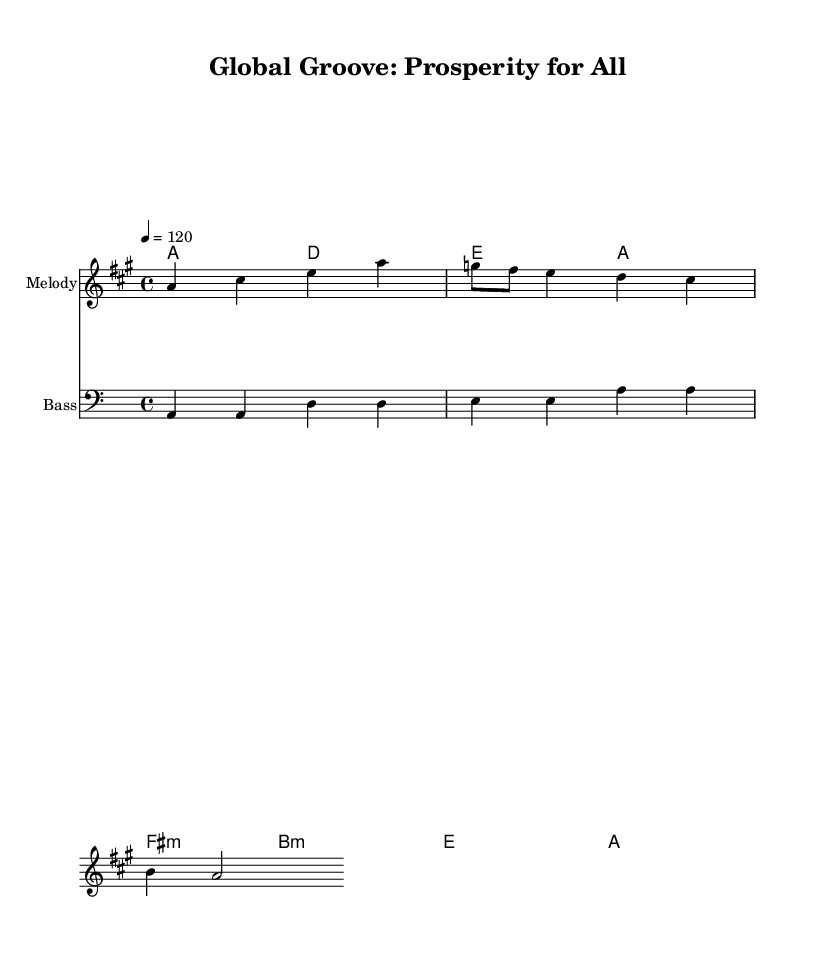What is the key signature of this music? The key signature is A major, which has three sharps: F sharp, C sharp, and G sharp. This can be seen in the global settings of the score.
Answer: A major What is the time signature of this music? The time signature is 4/4, meaning there are four beats in each measure and a quarter note gets one beat. This is specified in the global settings of the score.
Answer: 4/4 What is the tempo marking of this music? The tempo marking indicates a speed of 120 beats per minute, which is reflected in the global settings denoted by "4 = 120."
Answer: 120 What is the primary theme of the lyrics? The lyrics suggest a theme of unity and breaking down barriers in trade among nations, which is indicative of economic cooperation. This can be inferred from the lyrics provided.
Answer: Economic cooperation How many measures are there in the melody section? The melody has a total of four measures, which can be counted by identifying the distinct rhythmic groups in the melody line before reaching the lyrical section.
Answer: Four measures What chord is repeated most frequently in the harmonies? The A major chord is repeated frequently in the harmonies, as it appears multiple times throughout the harmonic progression indicated in the score.
Answer: A major What musical genre does this piece represent? This piece represents the disco genre, characterized by its upbeat tempo and danceable qualities, which can be inferred from the title and structure of the piece.
Answer: Disco 